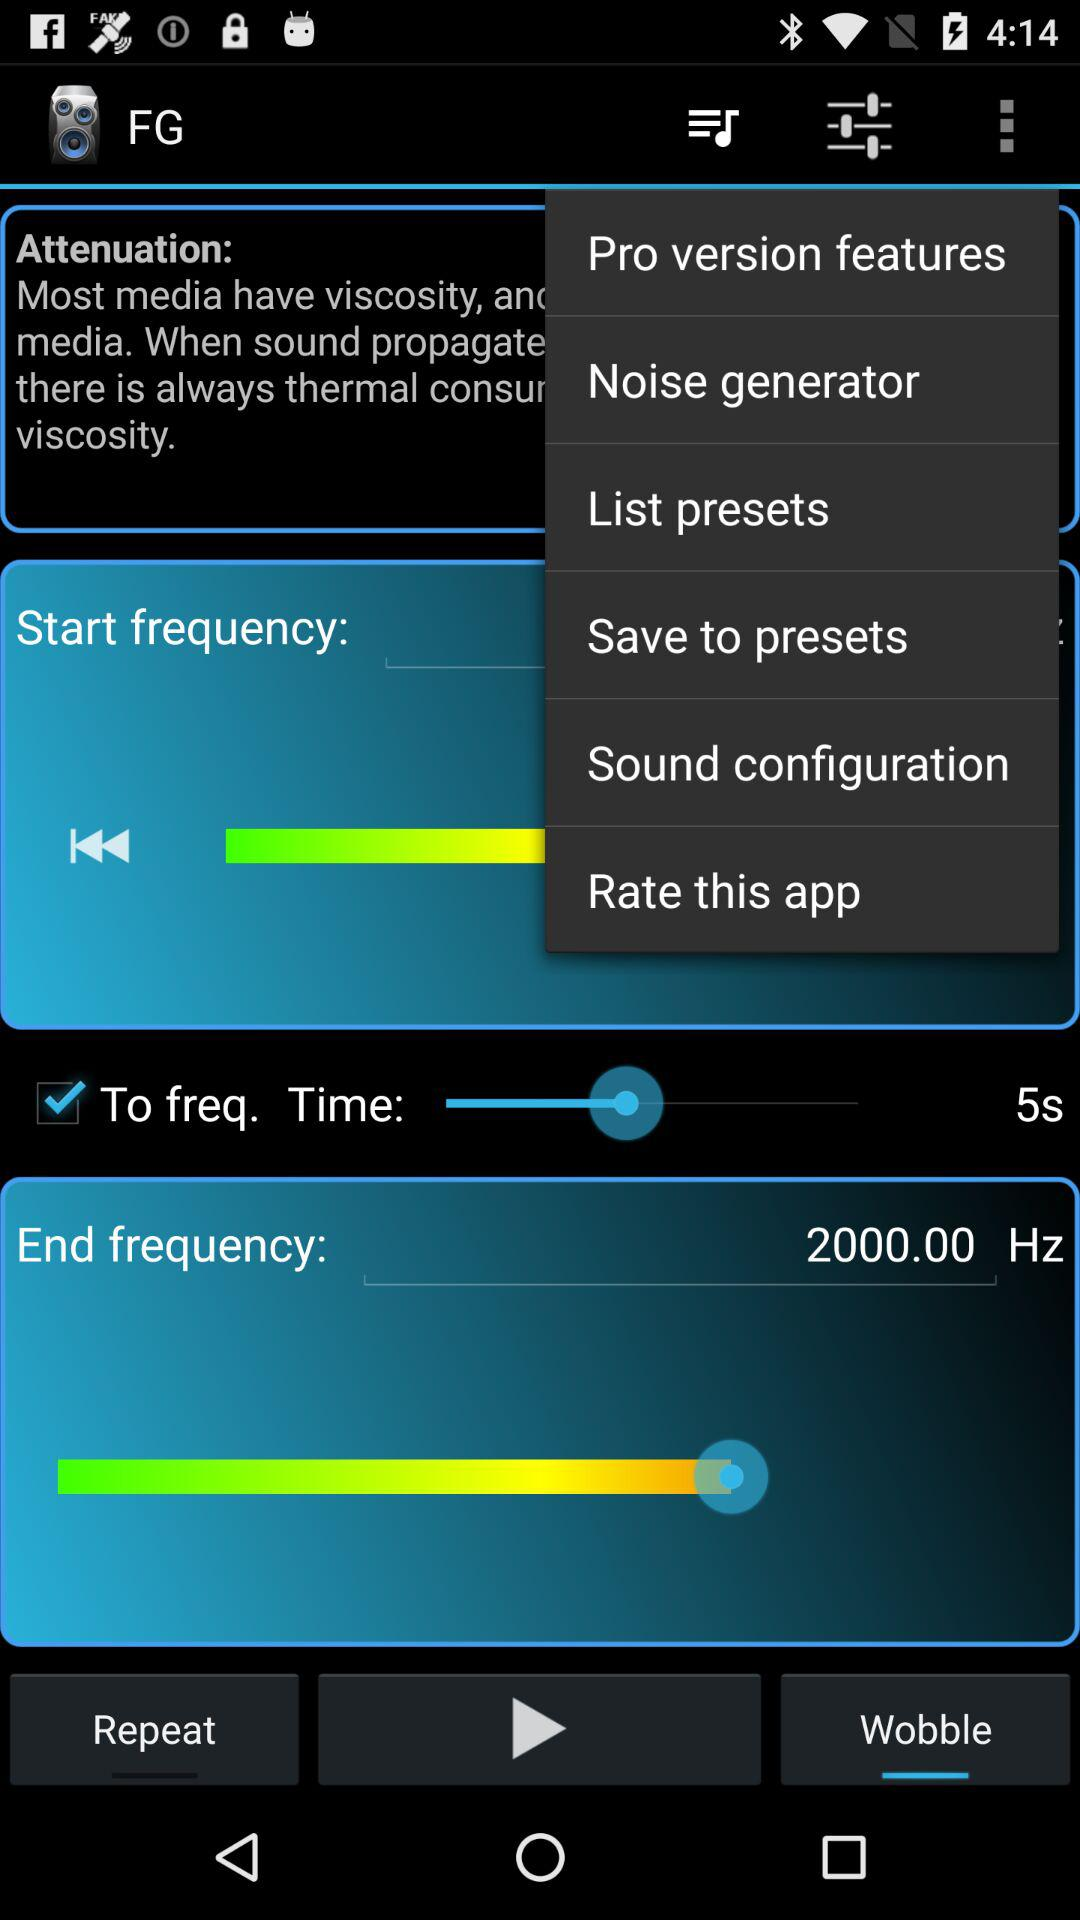Is "To freq." checked or unchecked?
Answer the question using a single word or phrase. It is checked. 